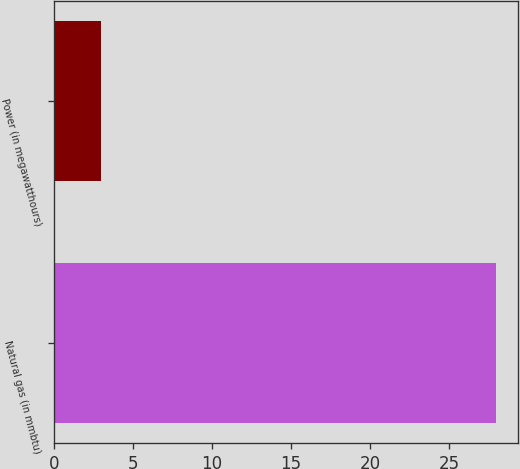Convert chart. <chart><loc_0><loc_0><loc_500><loc_500><bar_chart><fcel>Natural gas (in mmbtu)<fcel>Power (in megawatthours)<nl><fcel>28<fcel>3<nl></chart> 